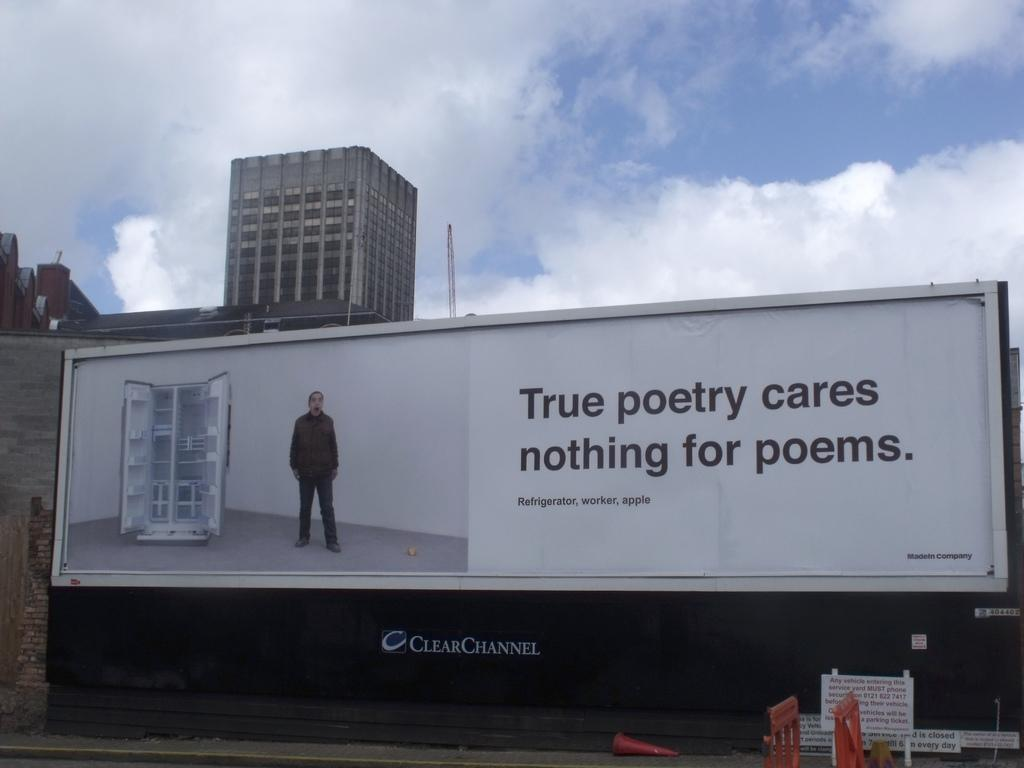<image>
Give a short and clear explanation of the subsequent image. A ClearChannel advertising billboard which shows a man next to an open refrigerator and the slogan True poetry cares nothing for poems. 